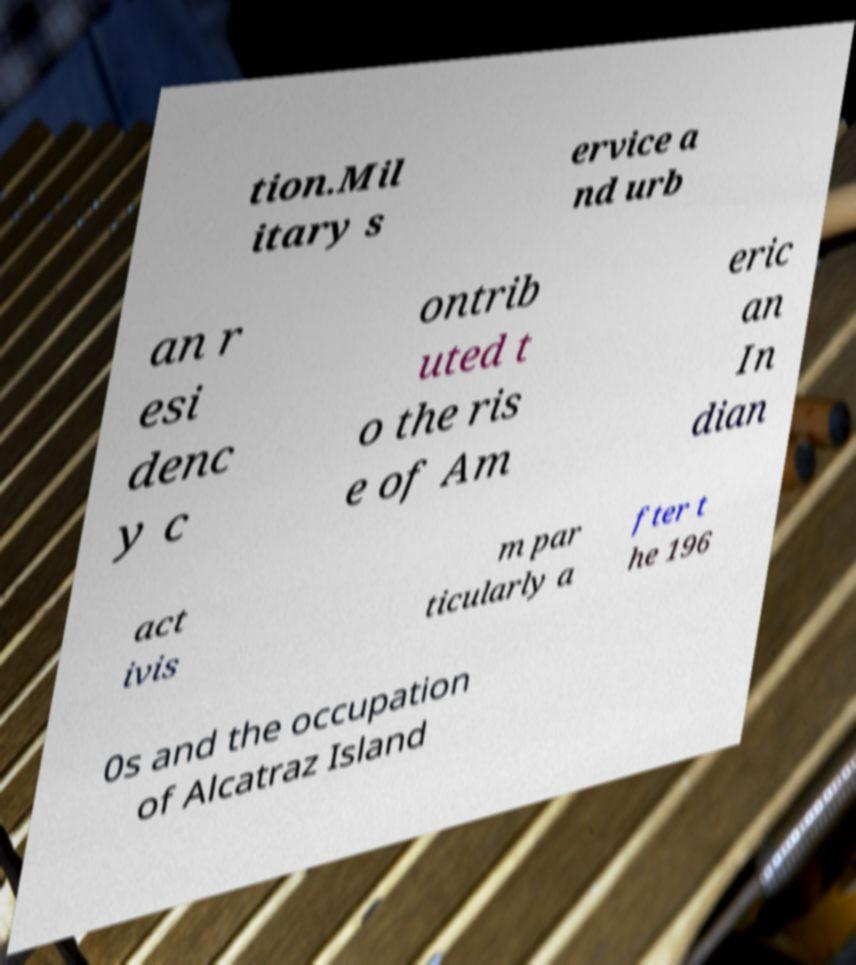There's text embedded in this image that I need extracted. Can you transcribe it verbatim? tion.Mil itary s ervice a nd urb an r esi denc y c ontrib uted t o the ris e of Am eric an In dian act ivis m par ticularly a fter t he 196 0s and the occupation of Alcatraz Island 